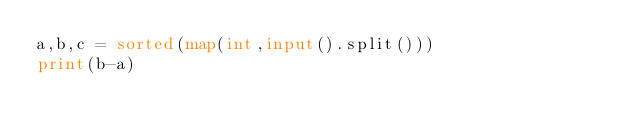Convert code to text. <code><loc_0><loc_0><loc_500><loc_500><_Python_>a,b,c = sorted(map(int,input().split()))
print(b-a)






</code> 